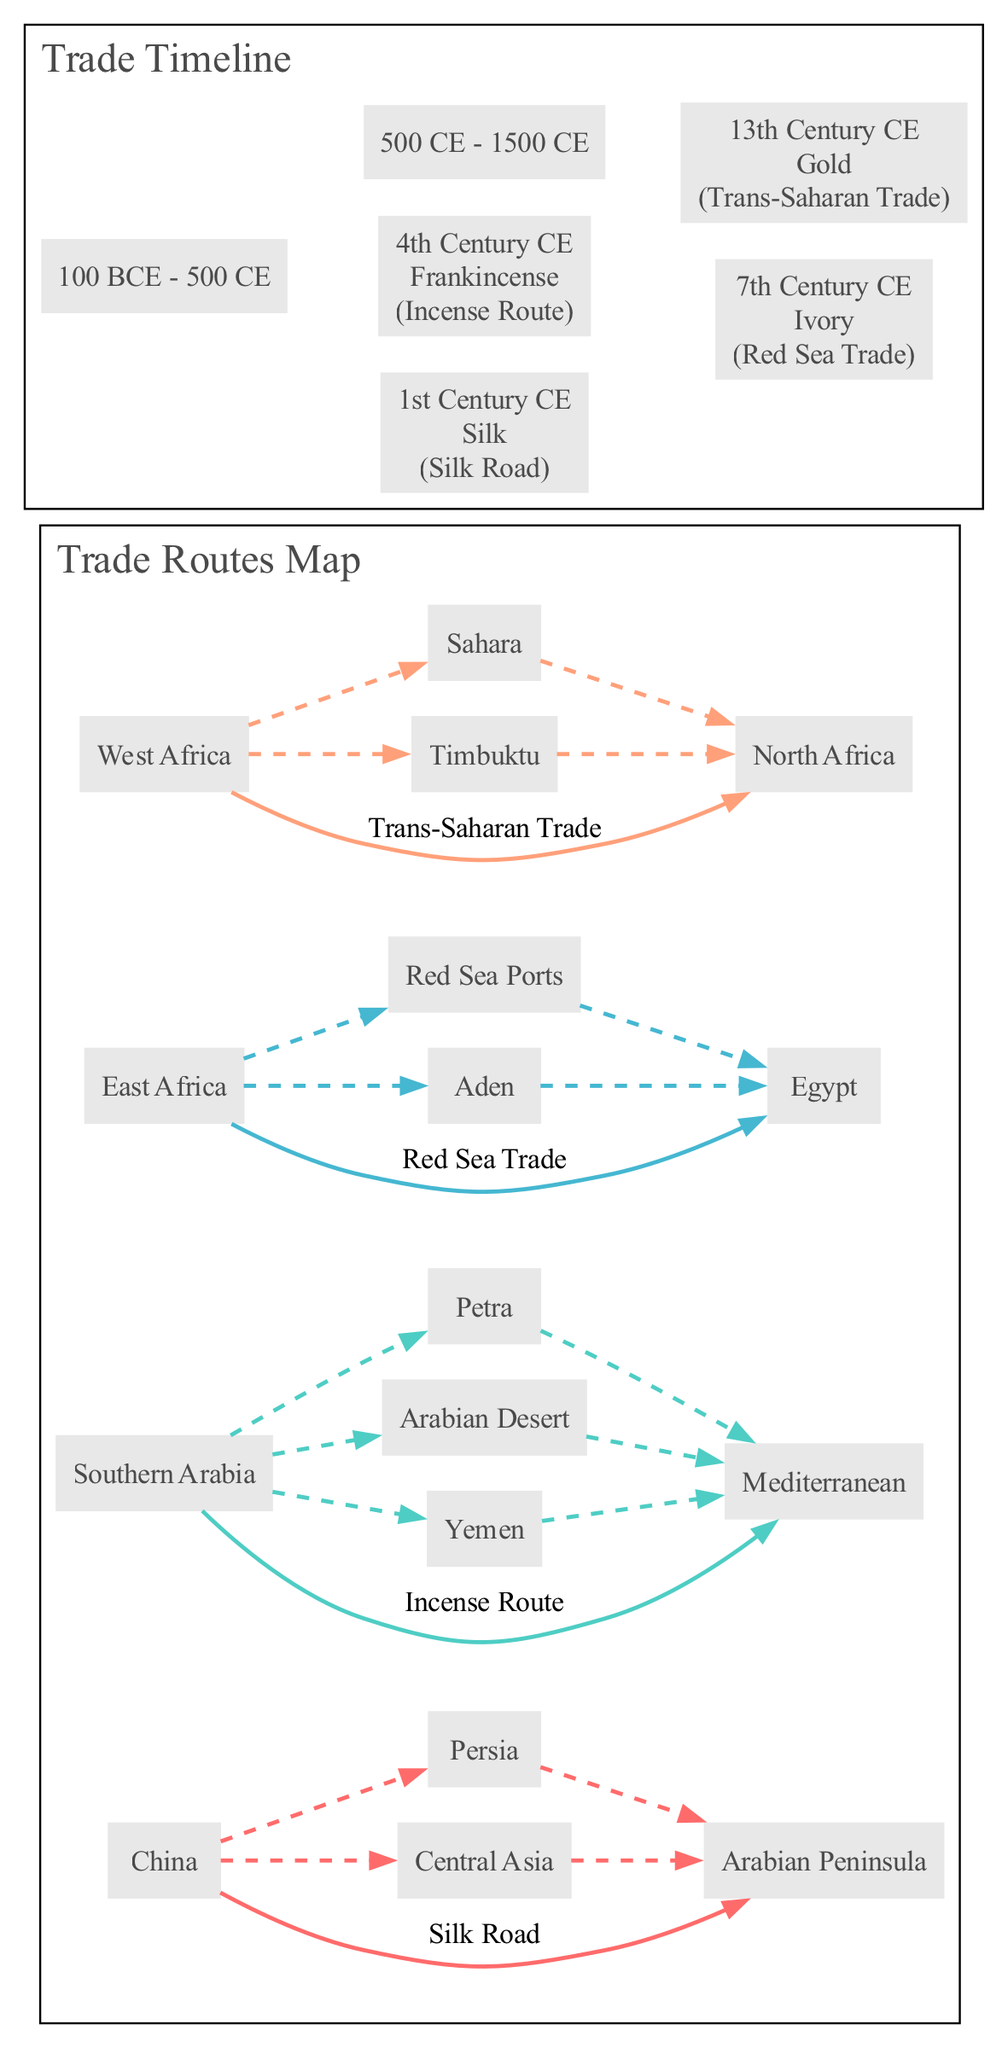What is the starting point of the Silk Road? The diagram indicates that the Silk Road starts in China.
Answer: China Which goods were exchanged on the Incense Route? According to the diagram, the goods exchanged on the Incense Route are Frankincense and Myrrh.
Answer: Frankincense, Myrrh How many main trade routes are depicted in the map? The map features four main trade routes: Silk Road, Incense Route, Red Sea Trade, and Trans-Saharan Trade.
Answer: 4 In which century was Ivory exchanged along the Red Sea Trade route? The timeline shows that Ivory was exchanged along the Red Sea Trade route in the 7th Century CE.
Answer: 7th Century CE What goods were traded on the Trans-Saharan Trade route during the 13th Century CE? The diagram states that Gold was the good traded on the Trans-Saharan Trade route during the 13th Century CE.
Answer: Gold Which two routes involve the trade of Gold? The routes that involve the trade of Gold are the Red Sea Trade and the Trans-Saharan Trade.
Answer: Red Sea Trade, Trans-Saharan Trade What is the endpoint of the Incense Route? The Incense Route ends at the Mediterranean according to the diagram.
Answer: Mediterranean Which trade route connects East Africa to Egypt? The trade route that connects East Africa to Egypt is the Red Sea Trade.
Answer: Red Sea Trade 